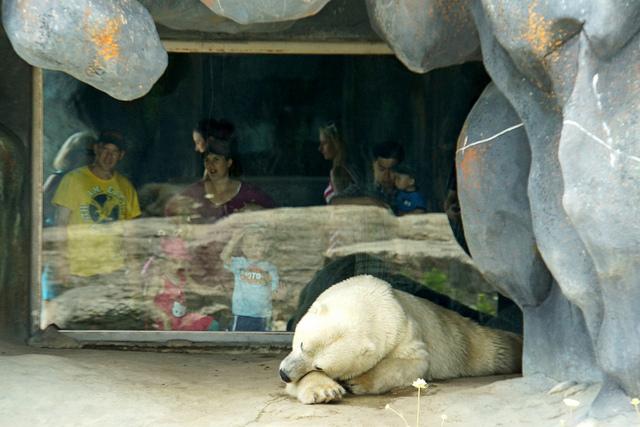Is the animal sleeping in a cave?
Keep it brief. No. What type of animal is this?
Write a very short answer. Polar bear. Is this a zoo?
Be succinct. Yes. 